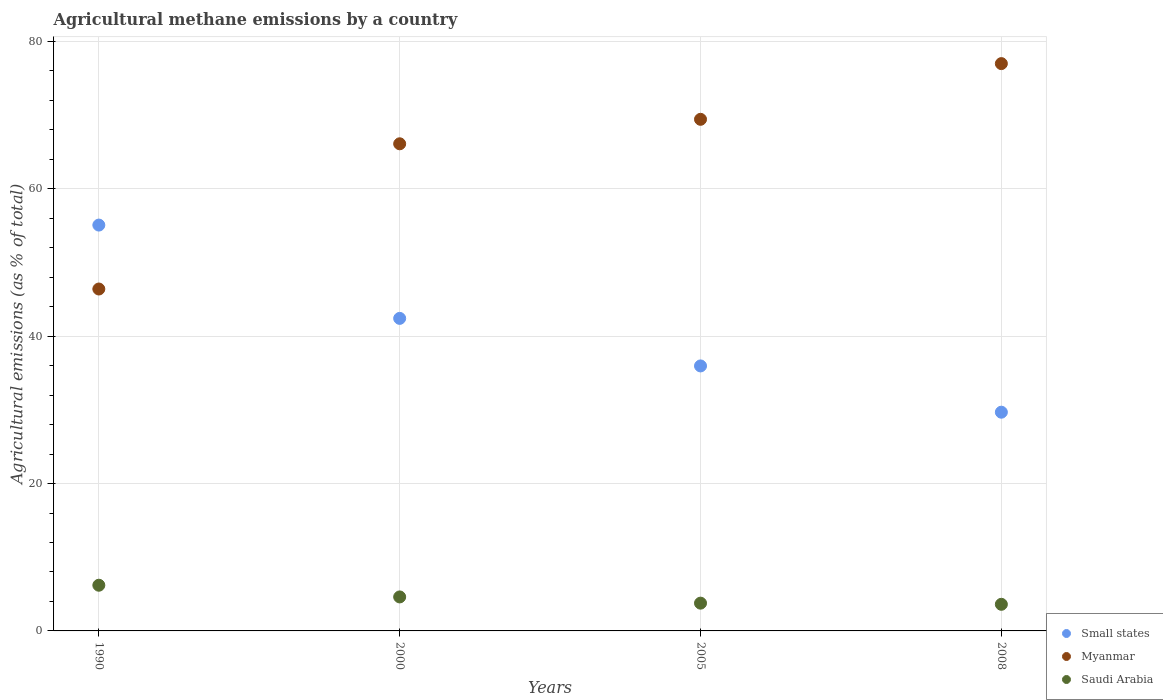How many different coloured dotlines are there?
Ensure brevity in your answer.  3. Is the number of dotlines equal to the number of legend labels?
Provide a short and direct response. Yes. What is the amount of agricultural methane emitted in Small states in 1990?
Offer a very short reply. 55.09. Across all years, what is the maximum amount of agricultural methane emitted in Small states?
Offer a terse response. 55.09. Across all years, what is the minimum amount of agricultural methane emitted in Saudi Arabia?
Your answer should be very brief. 3.61. In which year was the amount of agricultural methane emitted in Small states maximum?
Provide a short and direct response. 1990. What is the total amount of agricultural methane emitted in Saudi Arabia in the graph?
Provide a succinct answer. 18.2. What is the difference between the amount of agricultural methane emitted in Myanmar in 2005 and that in 2008?
Provide a succinct answer. -7.56. What is the difference between the amount of agricultural methane emitted in Saudi Arabia in 2000 and the amount of agricultural methane emitted in Myanmar in 2008?
Your answer should be compact. -72.39. What is the average amount of agricultural methane emitted in Myanmar per year?
Offer a terse response. 64.74. In the year 2008, what is the difference between the amount of agricultural methane emitted in Small states and amount of agricultural methane emitted in Saudi Arabia?
Give a very brief answer. 26.08. In how many years, is the amount of agricultural methane emitted in Myanmar greater than 24 %?
Make the answer very short. 4. What is the ratio of the amount of agricultural methane emitted in Saudi Arabia in 2000 to that in 2008?
Ensure brevity in your answer.  1.28. What is the difference between the highest and the second highest amount of agricultural methane emitted in Saudi Arabia?
Offer a very short reply. 1.59. What is the difference between the highest and the lowest amount of agricultural methane emitted in Small states?
Ensure brevity in your answer.  25.4. Is the sum of the amount of agricultural methane emitted in Small states in 2005 and 2008 greater than the maximum amount of agricultural methane emitted in Myanmar across all years?
Give a very brief answer. No. Does the amount of agricultural methane emitted in Myanmar monotonically increase over the years?
Provide a short and direct response. Yes. Is the amount of agricultural methane emitted in Small states strictly greater than the amount of agricultural methane emitted in Saudi Arabia over the years?
Make the answer very short. Yes. Is the amount of agricultural methane emitted in Myanmar strictly less than the amount of agricultural methane emitted in Saudi Arabia over the years?
Your answer should be compact. No. How many years are there in the graph?
Offer a terse response. 4. Does the graph contain any zero values?
Offer a terse response. No. How many legend labels are there?
Provide a succinct answer. 3. What is the title of the graph?
Ensure brevity in your answer.  Agricultural methane emissions by a country. What is the label or title of the X-axis?
Your response must be concise. Years. What is the label or title of the Y-axis?
Keep it short and to the point. Agricultural emissions (as % of total). What is the Agricultural emissions (as % of total) of Small states in 1990?
Give a very brief answer. 55.09. What is the Agricultural emissions (as % of total) of Myanmar in 1990?
Your response must be concise. 46.41. What is the Agricultural emissions (as % of total) in Saudi Arabia in 1990?
Give a very brief answer. 6.2. What is the Agricultural emissions (as % of total) in Small states in 2000?
Offer a very short reply. 42.42. What is the Agricultural emissions (as % of total) of Myanmar in 2000?
Give a very brief answer. 66.12. What is the Agricultural emissions (as % of total) of Saudi Arabia in 2000?
Keep it short and to the point. 4.61. What is the Agricultural emissions (as % of total) of Small states in 2005?
Provide a succinct answer. 35.97. What is the Agricultural emissions (as % of total) in Myanmar in 2005?
Provide a succinct answer. 69.44. What is the Agricultural emissions (as % of total) of Saudi Arabia in 2005?
Make the answer very short. 3.77. What is the Agricultural emissions (as % of total) of Small states in 2008?
Keep it short and to the point. 29.69. What is the Agricultural emissions (as % of total) of Myanmar in 2008?
Offer a terse response. 77. What is the Agricultural emissions (as % of total) of Saudi Arabia in 2008?
Keep it short and to the point. 3.61. Across all years, what is the maximum Agricultural emissions (as % of total) in Small states?
Ensure brevity in your answer.  55.09. Across all years, what is the maximum Agricultural emissions (as % of total) of Myanmar?
Keep it short and to the point. 77. Across all years, what is the maximum Agricultural emissions (as % of total) in Saudi Arabia?
Give a very brief answer. 6.2. Across all years, what is the minimum Agricultural emissions (as % of total) of Small states?
Your answer should be very brief. 29.69. Across all years, what is the minimum Agricultural emissions (as % of total) of Myanmar?
Offer a very short reply. 46.41. Across all years, what is the minimum Agricultural emissions (as % of total) in Saudi Arabia?
Provide a succinct answer. 3.61. What is the total Agricultural emissions (as % of total) in Small states in the graph?
Your answer should be compact. 163.16. What is the total Agricultural emissions (as % of total) in Myanmar in the graph?
Offer a terse response. 258.97. What is the total Agricultural emissions (as % of total) in Saudi Arabia in the graph?
Offer a very short reply. 18.2. What is the difference between the Agricultural emissions (as % of total) in Small states in 1990 and that in 2000?
Your answer should be very brief. 12.66. What is the difference between the Agricultural emissions (as % of total) of Myanmar in 1990 and that in 2000?
Provide a succinct answer. -19.71. What is the difference between the Agricultural emissions (as % of total) of Saudi Arabia in 1990 and that in 2000?
Make the answer very short. 1.59. What is the difference between the Agricultural emissions (as % of total) in Small states in 1990 and that in 2005?
Offer a very short reply. 19.12. What is the difference between the Agricultural emissions (as % of total) in Myanmar in 1990 and that in 2005?
Provide a short and direct response. -23.03. What is the difference between the Agricultural emissions (as % of total) of Saudi Arabia in 1990 and that in 2005?
Your response must be concise. 2.43. What is the difference between the Agricultural emissions (as % of total) of Small states in 1990 and that in 2008?
Give a very brief answer. 25.4. What is the difference between the Agricultural emissions (as % of total) in Myanmar in 1990 and that in 2008?
Give a very brief answer. -30.59. What is the difference between the Agricultural emissions (as % of total) in Saudi Arabia in 1990 and that in 2008?
Make the answer very short. 2.59. What is the difference between the Agricultural emissions (as % of total) in Small states in 2000 and that in 2005?
Provide a succinct answer. 6.45. What is the difference between the Agricultural emissions (as % of total) of Myanmar in 2000 and that in 2005?
Ensure brevity in your answer.  -3.32. What is the difference between the Agricultural emissions (as % of total) in Saudi Arabia in 2000 and that in 2005?
Your response must be concise. 0.84. What is the difference between the Agricultural emissions (as % of total) in Small states in 2000 and that in 2008?
Make the answer very short. 12.73. What is the difference between the Agricultural emissions (as % of total) of Myanmar in 2000 and that in 2008?
Your response must be concise. -10.88. What is the difference between the Agricultural emissions (as % of total) in Small states in 2005 and that in 2008?
Keep it short and to the point. 6.28. What is the difference between the Agricultural emissions (as % of total) of Myanmar in 2005 and that in 2008?
Your answer should be compact. -7.56. What is the difference between the Agricultural emissions (as % of total) in Saudi Arabia in 2005 and that in 2008?
Provide a succinct answer. 0.16. What is the difference between the Agricultural emissions (as % of total) in Small states in 1990 and the Agricultural emissions (as % of total) in Myanmar in 2000?
Your response must be concise. -11.03. What is the difference between the Agricultural emissions (as % of total) in Small states in 1990 and the Agricultural emissions (as % of total) in Saudi Arabia in 2000?
Offer a very short reply. 50.47. What is the difference between the Agricultural emissions (as % of total) of Myanmar in 1990 and the Agricultural emissions (as % of total) of Saudi Arabia in 2000?
Provide a succinct answer. 41.79. What is the difference between the Agricultural emissions (as % of total) in Small states in 1990 and the Agricultural emissions (as % of total) in Myanmar in 2005?
Make the answer very short. -14.36. What is the difference between the Agricultural emissions (as % of total) of Small states in 1990 and the Agricultural emissions (as % of total) of Saudi Arabia in 2005?
Offer a terse response. 51.32. What is the difference between the Agricultural emissions (as % of total) of Myanmar in 1990 and the Agricultural emissions (as % of total) of Saudi Arabia in 2005?
Your answer should be compact. 42.64. What is the difference between the Agricultural emissions (as % of total) in Small states in 1990 and the Agricultural emissions (as % of total) in Myanmar in 2008?
Give a very brief answer. -21.92. What is the difference between the Agricultural emissions (as % of total) of Small states in 1990 and the Agricultural emissions (as % of total) of Saudi Arabia in 2008?
Your answer should be compact. 51.47. What is the difference between the Agricultural emissions (as % of total) of Myanmar in 1990 and the Agricultural emissions (as % of total) of Saudi Arabia in 2008?
Offer a terse response. 42.8. What is the difference between the Agricultural emissions (as % of total) of Small states in 2000 and the Agricultural emissions (as % of total) of Myanmar in 2005?
Ensure brevity in your answer.  -27.02. What is the difference between the Agricultural emissions (as % of total) of Small states in 2000 and the Agricultural emissions (as % of total) of Saudi Arabia in 2005?
Provide a succinct answer. 38.65. What is the difference between the Agricultural emissions (as % of total) in Myanmar in 2000 and the Agricultural emissions (as % of total) in Saudi Arabia in 2005?
Your response must be concise. 62.35. What is the difference between the Agricultural emissions (as % of total) in Small states in 2000 and the Agricultural emissions (as % of total) in Myanmar in 2008?
Your answer should be very brief. -34.58. What is the difference between the Agricultural emissions (as % of total) in Small states in 2000 and the Agricultural emissions (as % of total) in Saudi Arabia in 2008?
Your response must be concise. 38.81. What is the difference between the Agricultural emissions (as % of total) in Myanmar in 2000 and the Agricultural emissions (as % of total) in Saudi Arabia in 2008?
Make the answer very short. 62.51. What is the difference between the Agricultural emissions (as % of total) of Small states in 2005 and the Agricultural emissions (as % of total) of Myanmar in 2008?
Provide a succinct answer. -41.03. What is the difference between the Agricultural emissions (as % of total) in Small states in 2005 and the Agricultural emissions (as % of total) in Saudi Arabia in 2008?
Offer a terse response. 32.36. What is the difference between the Agricultural emissions (as % of total) of Myanmar in 2005 and the Agricultural emissions (as % of total) of Saudi Arabia in 2008?
Make the answer very short. 65.83. What is the average Agricultural emissions (as % of total) of Small states per year?
Offer a terse response. 40.79. What is the average Agricultural emissions (as % of total) of Myanmar per year?
Your response must be concise. 64.74. What is the average Agricultural emissions (as % of total) in Saudi Arabia per year?
Ensure brevity in your answer.  4.55. In the year 1990, what is the difference between the Agricultural emissions (as % of total) of Small states and Agricultural emissions (as % of total) of Myanmar?
Provide a short and direct response. 8.68. In the year 1990, what is the difference between the Agricultural emissions (as % of total) in Small states and Agricultural emissions (as % of total) in Saudi Arabia?
Provide a short and direct response. 48.88. In the year 1990, what is the difference between the Agricultural emissions (as % of total) in Myanmar and Agricultural emissions (as % of total) in Saudi Arabia?
Keep it short and to the point. 40.21. In the year 2000, what is the difference between the Agricultural emissions (as % of total) in Small states and Agricultural emissions (as % of total) in Myanmar?
Give a very brief answer. -23.7. In the year 2000, what is the difference between the Agricultural emissions (as % of total) of Small states and Agricultural emissions (as % of total) of Saudi Arabia?
Provide a succinct answer. 37.81. In the year 2000, what is the difference between the Agricultural emissions (as % of total) in Myanmar and Agricultural emissions (as % of total) in Saudi Arabia?
Provide a succinct answer. 61.5. In the year 2005, what is the difference between the Agricultural emissions (as % of total) of Small states and Agricultural emissions (as % of total) of Myanmar?
Offer a very short reply. -33.47. In the year 2005, what is the difference between the Agricultural emissions (as % of total) in Small states and Agricultural emissions (as % of total) in Saudi Arabia?
Keep it short and to the point. 32.2. In the year 2005, what is the difference between the Agricultural emissions (as % of total) in Myanmar and Agricultural emissions (as % of total) in Saudi Arabia?
Your answer should be compact. 65.67. In the year 2008, what is the difference between the Agricultural emissions (as % of total) in Small states and Agricultural emissions (as % of total) in Myanmar?
Provide a short and direct response. -47.31. In the year 2008, what is the difference between the Agricultural emissions (as % of total) in Small states and Agricultural emissions (as % of total) in Saudi Arabia?
Ensure brevity in your answer.  26.08. In the year 2008, what is the difference between the Agricultural emissions (as % of total) in Myanmar and Agricultural emissions (as % of total) in Saudi Arabia?
Offer a very short reply. 73.39. What is the ratio of the Agricultural emissions (as % of total) of Small states in 1990 to that in 2000?
Offer a very short reply. 1.3. What is the ratio of the Agricultural emissions (as % of total) of Myanmar in 1990 to that in 2000?
Offer a very short reply. 0.7. What is the ratio of the Agricultural emissions (as % of total) of Saudi Arabia in 1990 to that in 2000?
Offer a very short reply. 1.34. What is the ratio of the Agricultural emissions (as % of total) of Small states in 1990 to that in 2005?
Make the answer very short. 1.53. What is the ratio of the Agricultural emissions (as % of total) of Myanmar in 1990 to that in 2005?
Provide a succinct answer. 0.67. What is the ratio of the Agricultural emissions (as % of total) of Saudi Arabia in 1990 to that in 2005?
Ensure brevity in your answer.  1.65. What is the ratio of the Agricultural emissions (as % of total) of Small states in 1990 to that in 2008?
Keep it short and to the point. 1.86. What is the ratio of the Agricultural emissions (as % of total) of Myanmar in 1990 to that in 2008?
Your response must be concise. 0.6. What is the ratio of the Agricultural emissions (as % of total) of Saudi Arabia in 1990 to that in 2008?
Provide a short and direct response. 1.72. What is the ratio of the Agricultural emissions (as % of total) of Small states in 2000 to that in 2005?
Provide a succinct answer. 1.18. What is the ratio of the Agricultural emissions (as % of total) in Myanmar in 2000 to that in 2005?
Ensure brevity in your answer.  0.95. What is the ratio of the Agricultural emissions (as % of total) in Saudi Arabia in 2000 to that in 2005?
Offer a very short reply. 1.22. What is the ratio of the Agricultural emissions (as % of total) of Small states in 2000 to that in 2008?
Offer a very short reply. 1.43. What is the ratio of the Agricultural emissions (as % of total) of Myanmar in 2000 to that in 2008?
Offer a terse response. 0.86. What is the ratio of the Agricultural emissions (as % of total) in Saudi Arabia in 2000 to that in 2008?
Keep it short and to the point. 1.28. What is the ratio of the Agricultural emissions (as % of total) in Small states in 2005 to that in 2008?
Provide a short and direct response. 1.21. What is the ratio of the Agricultural emissions (as % of total) in Myanmar in 2005 to that in 2008?
Keep it short and to the point. 0.9. What is the ratio of the Agricultural emissions (as % of total) in Saudi Arabia in 2005 to that in 2008?
Provide a succinct answer. 1.04. What is the difference between the highest and the second highest Agricultural emissions (as % of total) in Small states?
Offer a terse response. 12.66. What is the difference between the highest and the second highest Agricultural emissions (as % of total) of Myanmar?
Your response must be concise. 7.56. What is the difference between the highest and the second highest Agricultural emissions (as % of total) of Saudi Arabia?
Ensure brevity in your answer.  1.59. What is the difference between the highest and the lowest Agricultural emissions (as % of total) of Small states?
Your answer should be compact. 25.4. What is the difference between the highest and the lowest Agricultural emissions (as % of total) in Myanmar?
Your response must be concise. 30.59. What is the difference between the highest and the lowest Agricultural emissions (as % of total) in Saudi Arabia?
Provide a succinct answer. 2.59. 